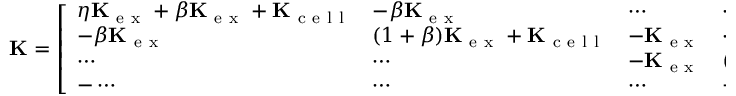<formula> <loc_0><loc_0><loc_500><loc_500>K = \left [ \begin{array} { l l l l l } { \eta K _ { e x } + \beta K _ { e x } + K _ { c e l l } } & { - \beta K _ { e x } } & { \cdots } & { \cdots } & { \cdots } \\ { - \beta K _ { e x } } & { ( 1 + \beta ) K _ { e x } + K _ { c e l l } } & { - K _ { e x } } & { \cdots } & { \cdots } \\ { \cdots } & { \cdots } & { - K _ { e x } } & { ( 1 + \beta ) K _ { e x } + K _ { c e l l } } & { - \beta K _ { e x } } \\ { - \cdots } & { \cdots } & { \cdots } & { - \beta K _ { e x } } & { \zeta K _ { e x } + \beta K _ { e x } + K _ { c e l l } } \end{array} \right ] \, .</formula> 